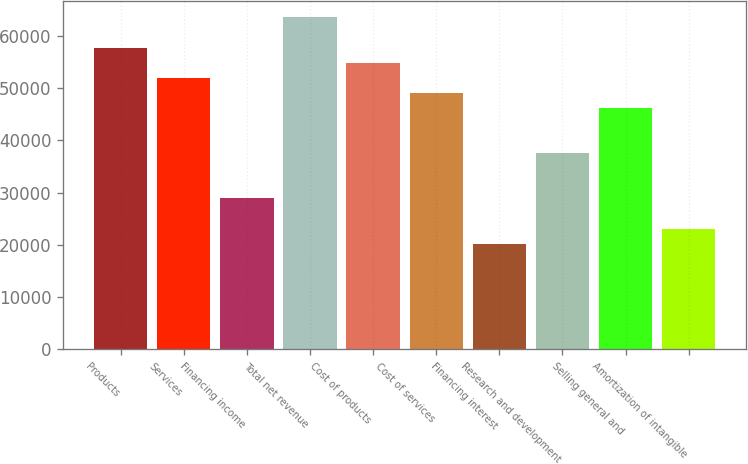<chart> <loc_0><loc_0><loc_500><loc_500><bar_chart><fcel>Products<fcel>Services<fcel>Financing income<fcel>Total net revenue<fcel>Cost of products<fcel>Cost of services<fcel>Financing interest<fcel>Research and development<fcel>Selling general and<fcel>Amortization of intangible<nl><fcel>57742<fcel>51967.8<fcel>28871<fcel>63516.2<fcel>54854.9<fcel>49080.7<fcel>20209.7<fcel>37532.3<fcel>46193.6<fcel>23096.8<nl></chart> 